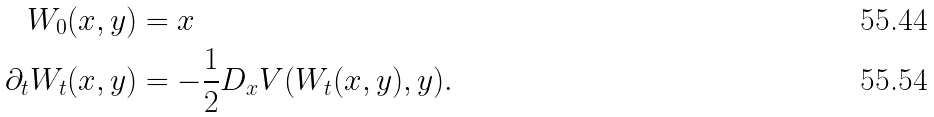Convert formula to latex. <formula><loc_0><loc_0><loc_500><loc_500>W _ { 0 } ( x , y ) & = x \\ \partial _ { t } W _ { t } ( x , y ) & = - \frac { 1 } { 2 } D _ { x } V ( W _ { t } ( x , y ) , y ) .</formula> 